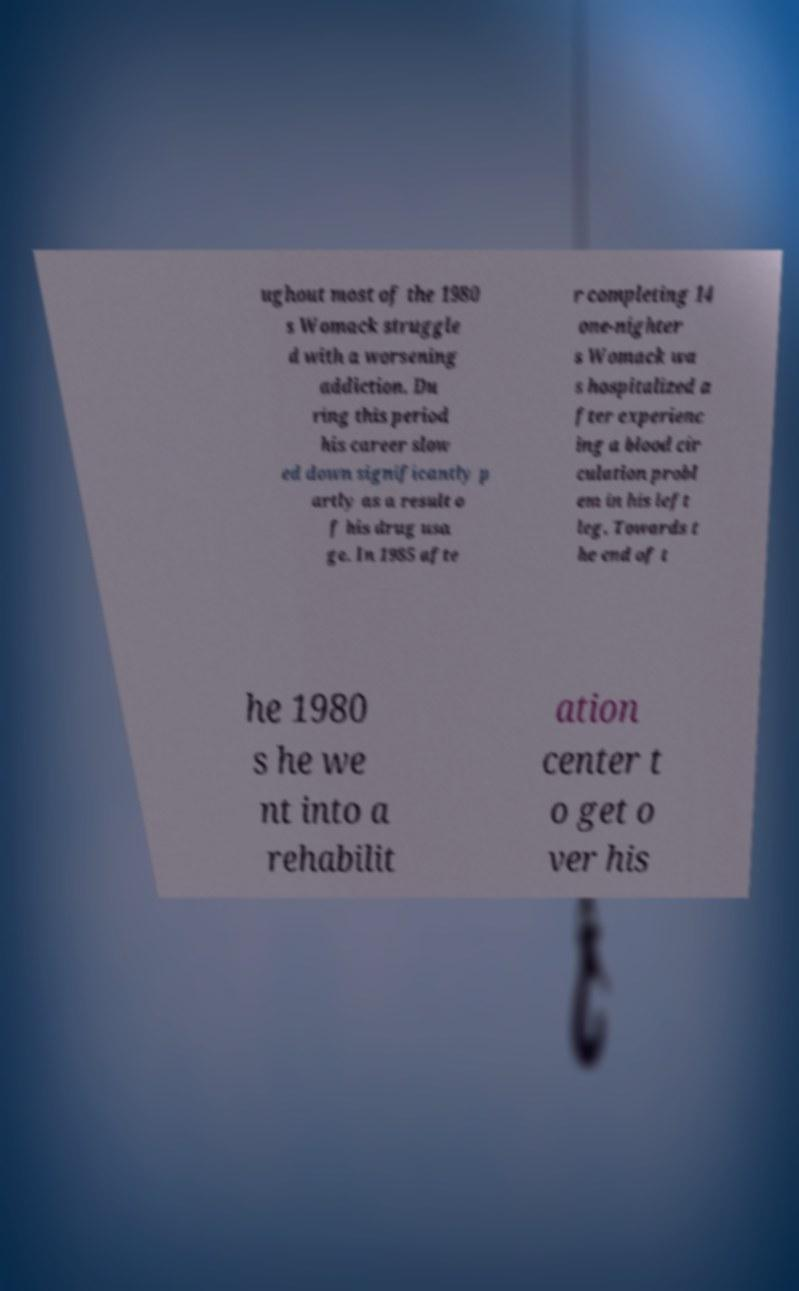Can you read and provide the text displayed in the image?This photo seems to have some interesting text. Can you extract and type it out for me? ughout most of the 1980 s Womack struggle d with a worsening addiction. Du ring this period his career slow ed down significantly p artly as a result o f his drug usa ge. In 1985 afte r completing 14 one-nighter s Womack wa s hospitalized a fter experienc ing a blood cir culation probl em in his left leg. Towards t he end of t he 1980 s he we nt into a rehabilit ation center t o get o ver his 